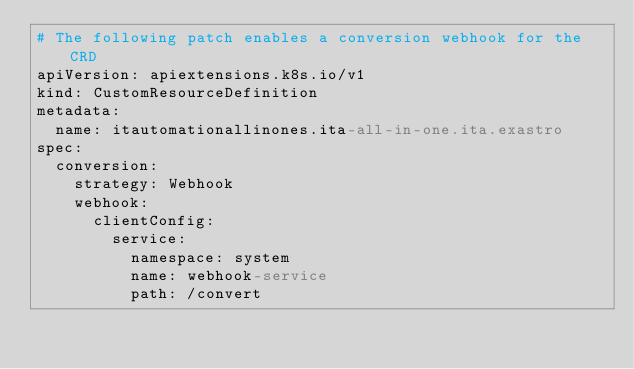Convert code to text. <code><loc_0><loc_0><loc_500><loc_500><_YAML_># The following patch enables a conversion webhook for the CRD
apiVersion: apiextensions.k8s.io/v1
kind: CustomResourceDefinition
metadata:
  name: itautomationallinones.ita-all-in-one.ita.exastro
spec:
  conversion:
    strategy: Webhook
    webhook:
      clientConfig:
        service:
          namespace: system
          name: webhook-service
          path: /convert
</code> 